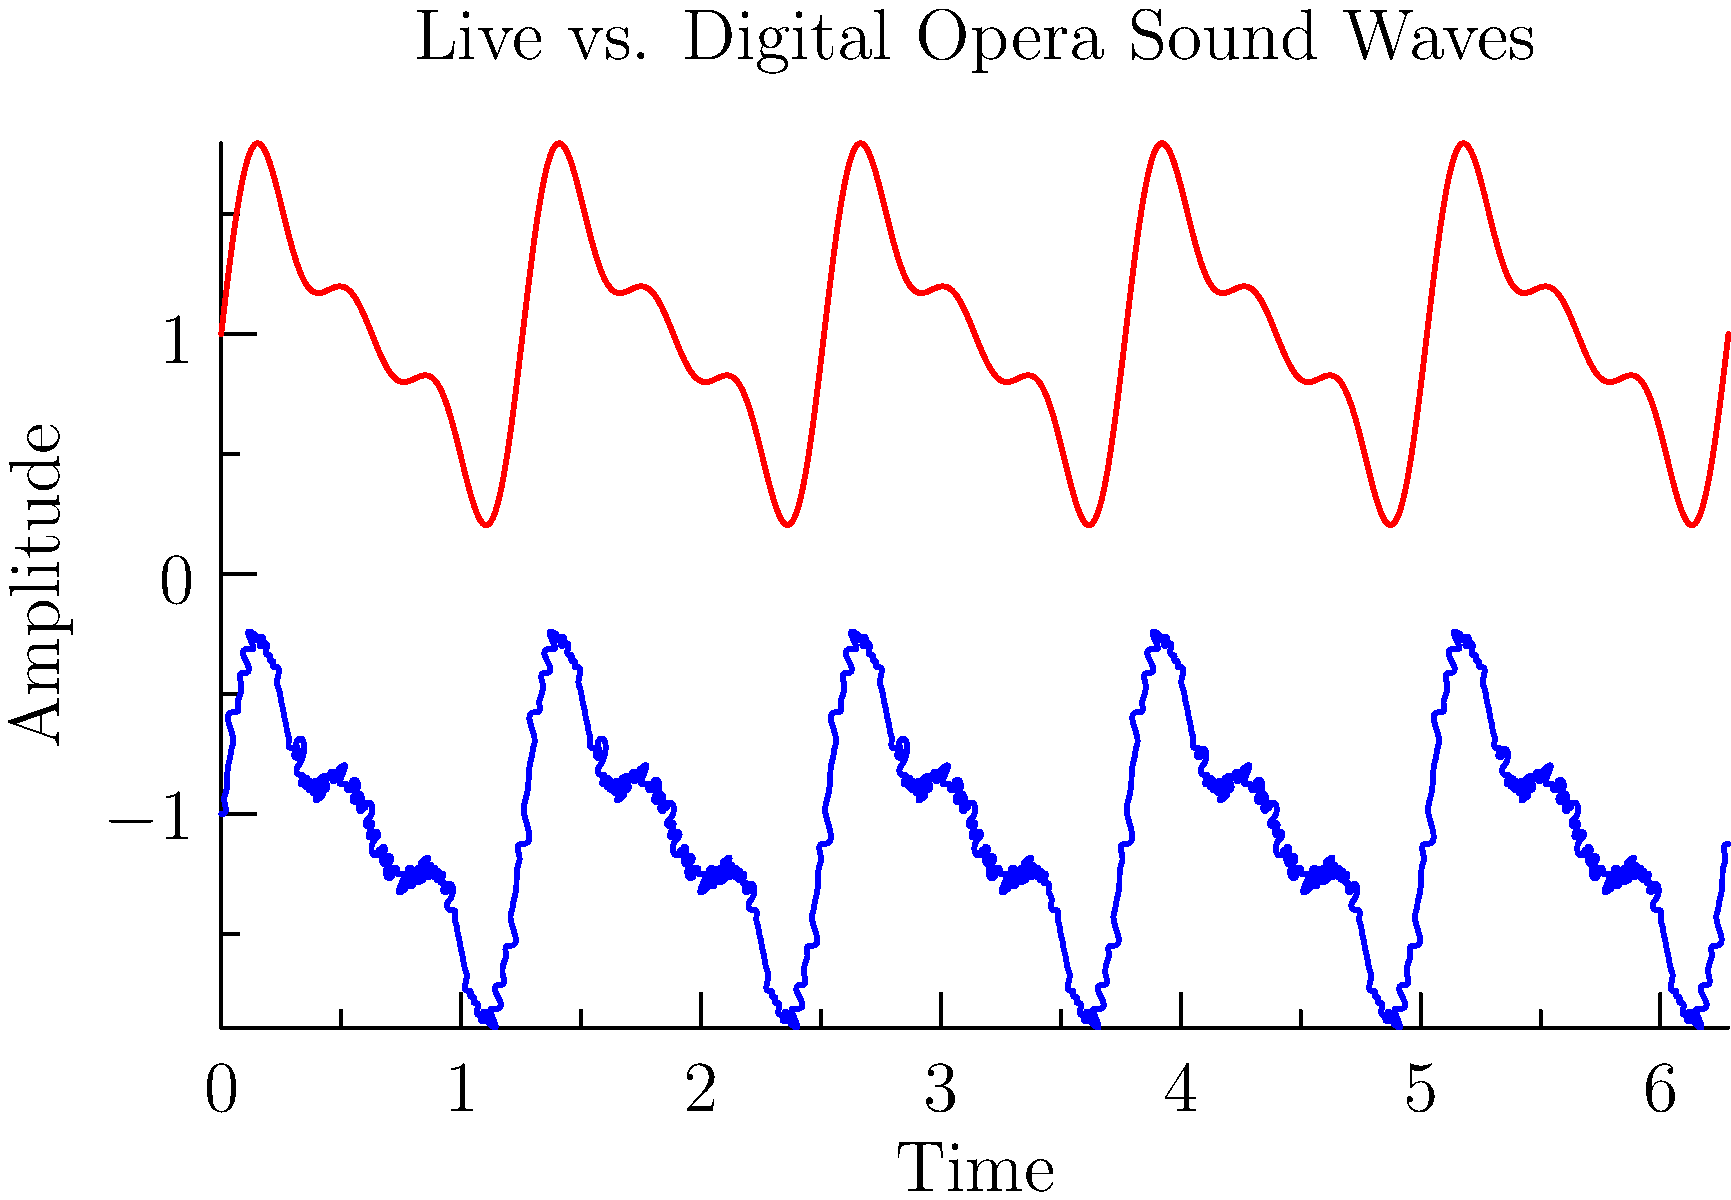Based on the graph comparing sound wave patterns of live and digitally recorded opera performances, which characteristic is most noticeably different between the two waveforms? To answer this question, let's analyze the graph step-by-step:

1. The red waveform represents the live performance, while the blue waveform represents the digital recording.

2. Observe the overall shape of both waveforms:
   - The live performance (red) shows a smooth, continuous curve.
   - The digital recording (blue) appears more jagged and stepped.

3. Consider the differences in detail:
   a) Amplitude: Both waveforms have similar overall amplitude ranges.
   b) Frequency: The general frequency patterns appear similar for both.
   c) Continuity: This is where we see the most significant difference.

4. The live performance waveform:
   - Has smooth transitions between points
   - Shows natural, organic fluctuations in the sound

5. The digital recording waveform:
   - Shows distinct steps or quantization
   - Represents the digital sampling process, where continuous sound is converted into discrete values

6. This stepped appearance in the digital waveform is due to the limitation in the number of possible amplitude values that can be represented digitally, known as bit depth or quantization.

Given these observations, the most noticeable difference between the two waveforms is the continuity or smoothness of the curve.
Answer: Continuity/smoothness 